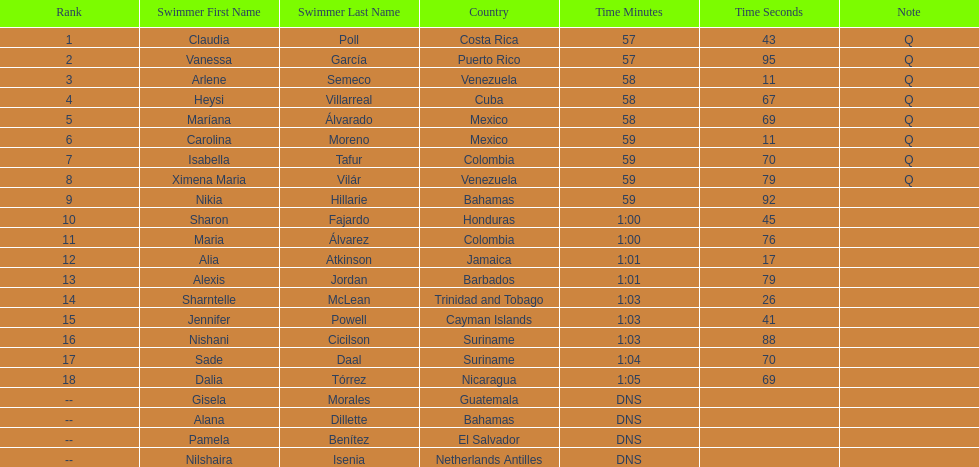What was claudia roll's time? 57.43. 